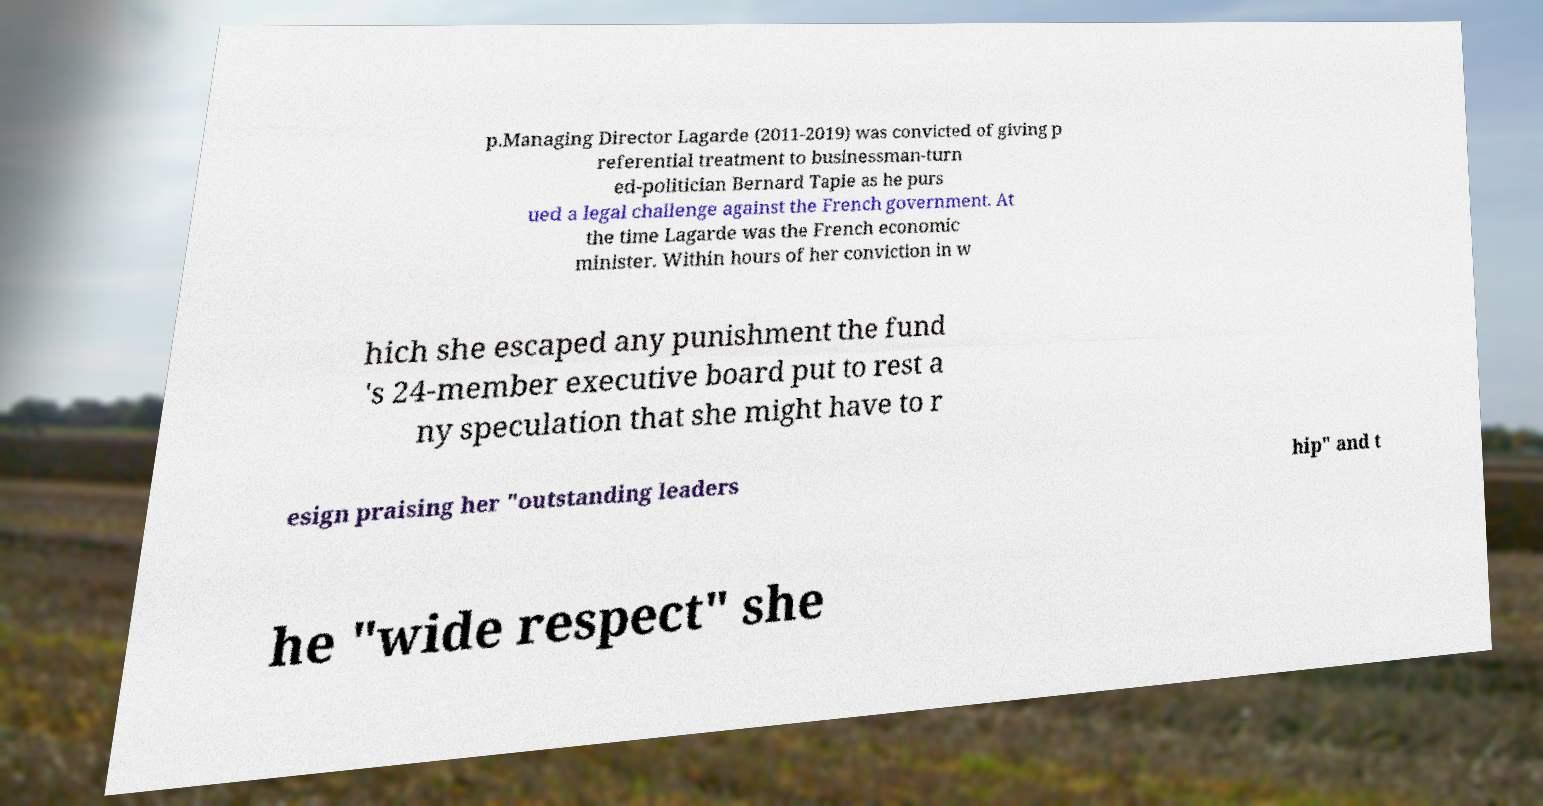I need the written content from this picture converted into text. Can you do that? p.Managing Director Lagarde (2011-2019) was convicted of giving p referential treatment to businessman-turn ed-politician Bernard Tapie as he purs ued a legal challenge against the French government. At the time Lagarde was the French economic minister. Within hours of her conviction in w hich she escaped any punishment the fund 's 24-member executive board put to rest a ny speculation that she might have to r esign praising her "outstanding leaders hip" and t he "wide respect" she 